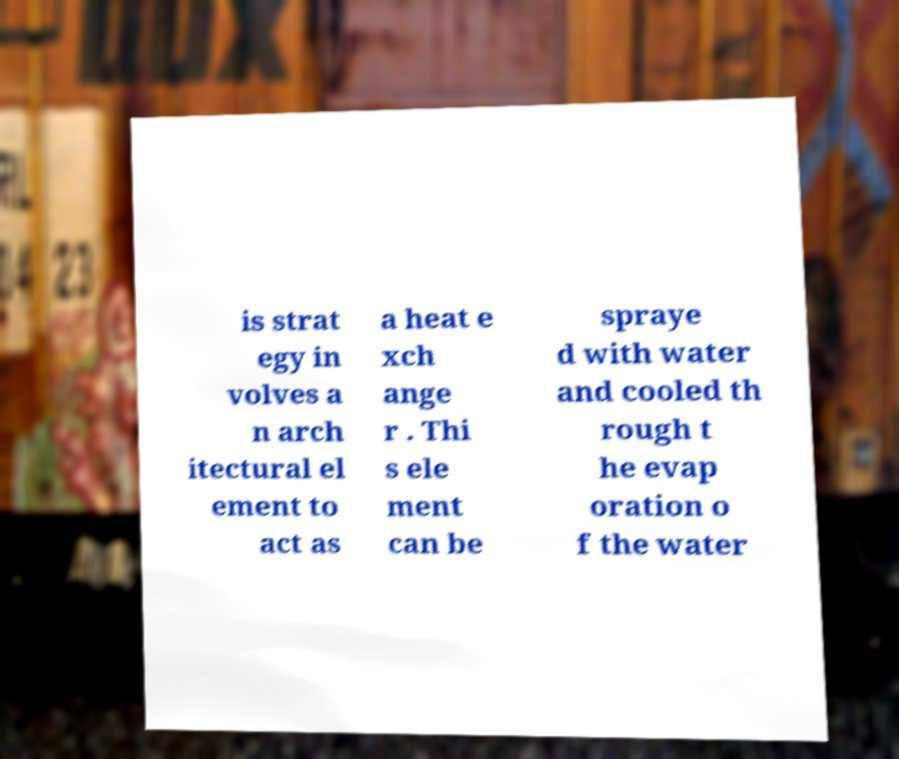What messages or text are displayed in this image? I need them in a readable, typed format. is strat egy in volves a n arch itectural el ement to act as a heat e xch ange r . Thi s ele ment can be spraye d with water and cooled th rough t he evap oration o f the water 